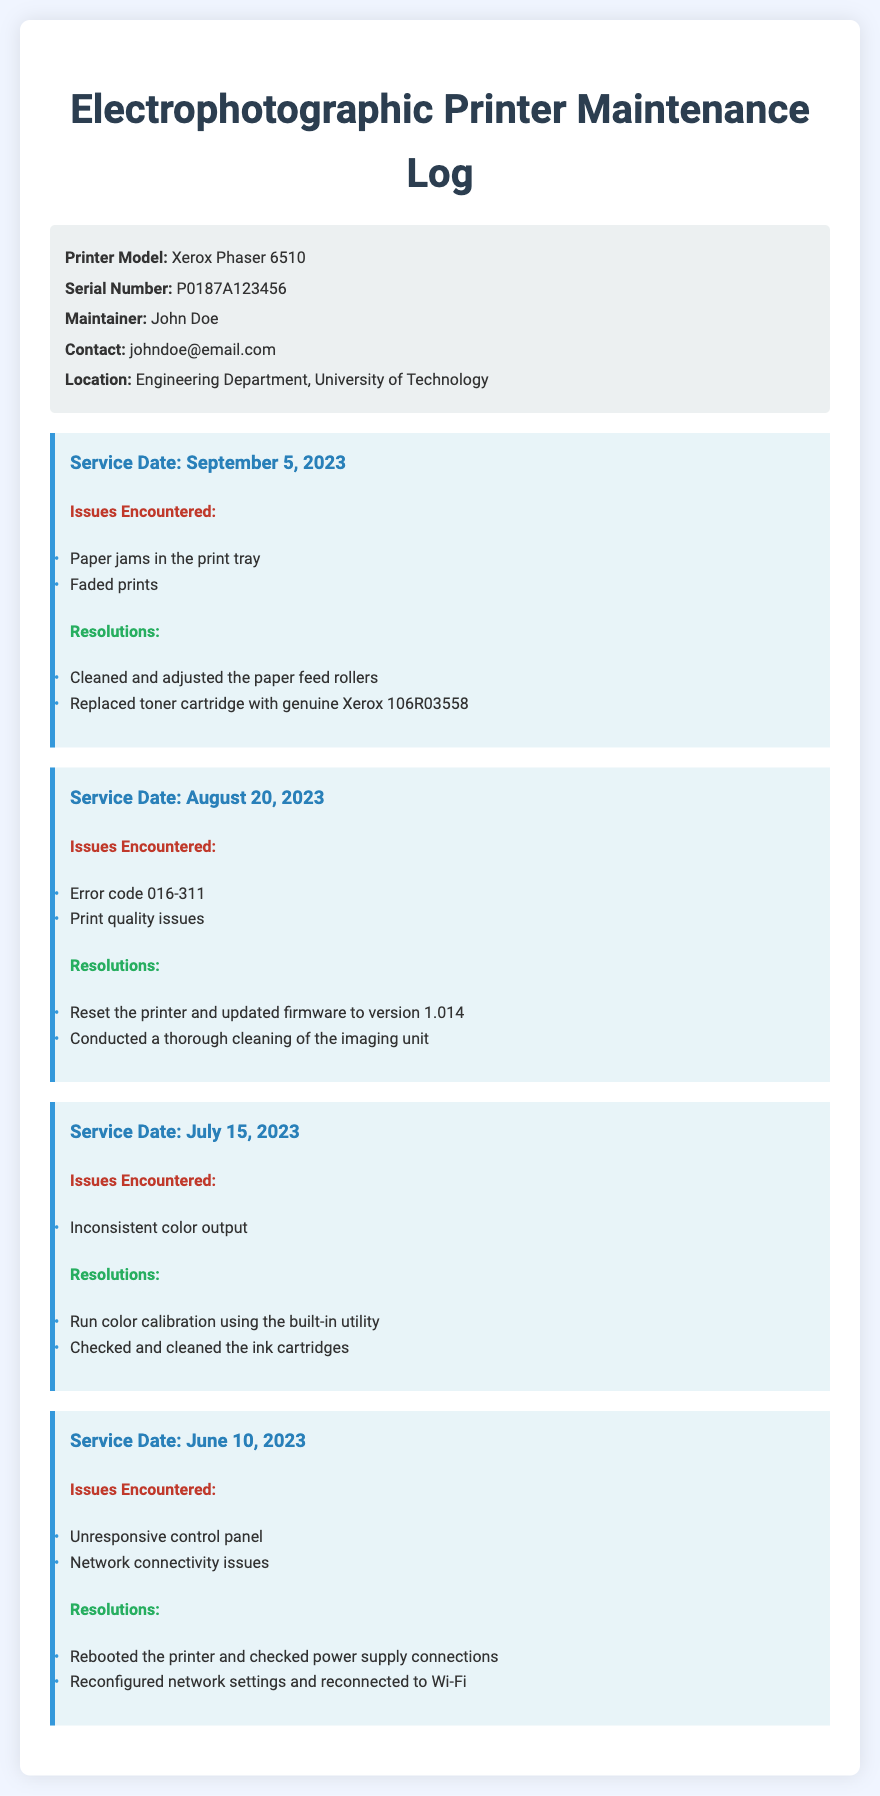What is the printer model? The document specifies the printer model as Xerox Phaser 6510.
Answer: Xerox Phaser 6510 Who is the maintainer of the printer? The document lists John Doe as the maintainer of the printer.
Answer: John Doe When was the last service date? The latest service date mentioned in the document is September 5, 2023.
Answer: September 5, 2023 What issue was encountered on August 20, 2023? On August 20, 2023, the document states that "Error code 016-311" was encountered.
Answer: Error code 016-311 What resolution was taken for faded prints? The document indicates that the toner cartridge was replaced with a genuine Xerox 106R03558 to resolve faded prints.
Answer: Replaced toner cartridge with genuine Xerox 106R03558 How many issues were recorded on June 10, 2023? The document lists two issues encountered on June 10, 2023: unresponsive control panel and network connectivity issues.
Answer: Two issues What maintenance action was performed for inconsistent color output? The document mentions that a color calibration was run using the built-in utility.
Answer: Run color calibration What firmware version was updated on August 20, 2023? The document states that the firmware was updated to version 1.014.
Answer: 1.014 What was the location of the printer? The document indicates that the printer is located in the Engineering Department, University of Technology.
Answer: Engineering Department, University of Technology 